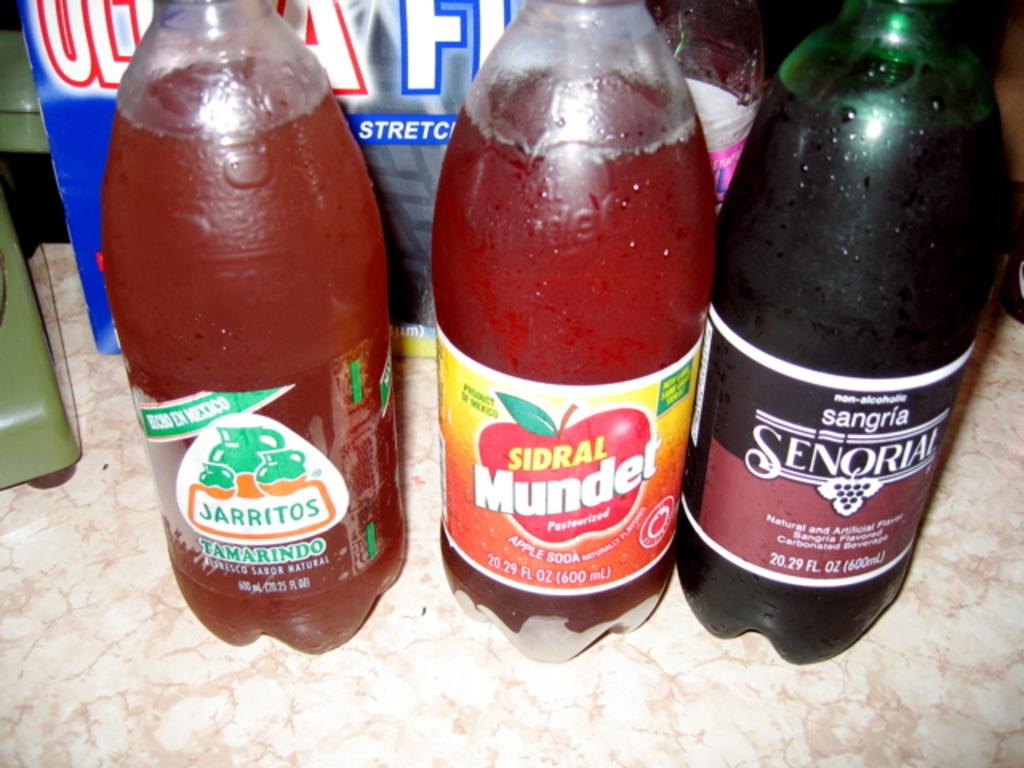<image>
Present a compact description of the photo's key features. Three bottles of soda called Jarritos, Sidral Mundet and Sangria senqriai 